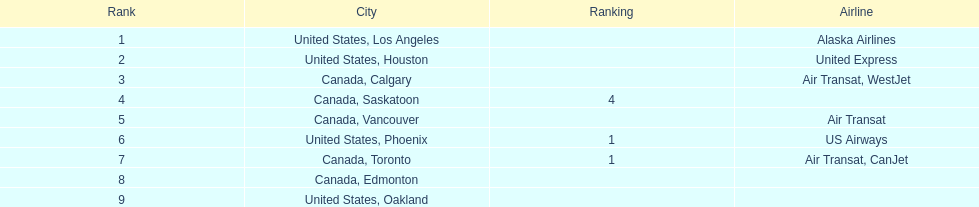Which airline carries the most passengers? Alaska Airlines. Can you parse all the data within this table? {'header': ['Rank', 'City', 'Ranking', 'Airline'], 'rows': [['1', 'United States, Los Angeles', '', 'Alaska Airlines'], ['2', 'United States, Houston', '', 'United Express'], ['3', 'Canada, Calgary', '', 'Air Transat, WestJet'], ['4', 'Canada, Saskatoon', '4', ''], ['5', 'Canada, Vancouver', '', 'Air Transat'], ['6', 'United States, Phoenix', '1', 'US Airways'], ['7', 'Canada, Toronto', '1', 'Air Transat, CanJet'], ['8', 'Canada, Edmonton', '', ''], ['9', 'United States, Oakland', '', '']]} 